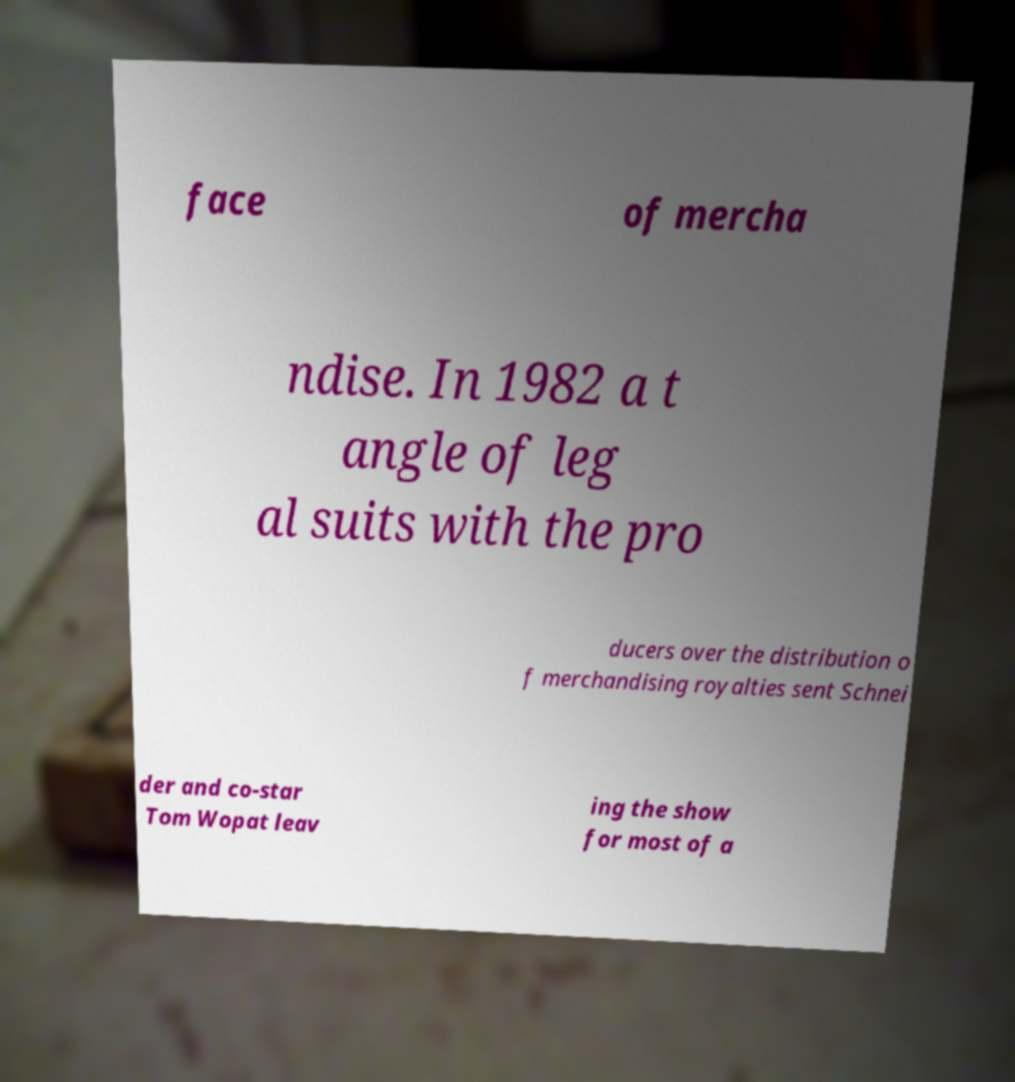Can you accurately transcribe the text from the provided image for me? face of mercha ndise. In 1982 a t angle of leg al suits with the pro ducers over the distribution o f merchandising royalties sent Schnei der and co-star Tom Wopat leav ing the show for most of a 